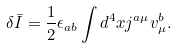Convert formula to latex. <formula><loc_0><loc_0><loc_500><loc_500>\delta { \bar { I } } = \frac { 1 } { 2 } \epsilon _ { a b } \int d ^ { 4 } x j ^ { a \mu } v ^ { b } _ { \mu } .</formula> 